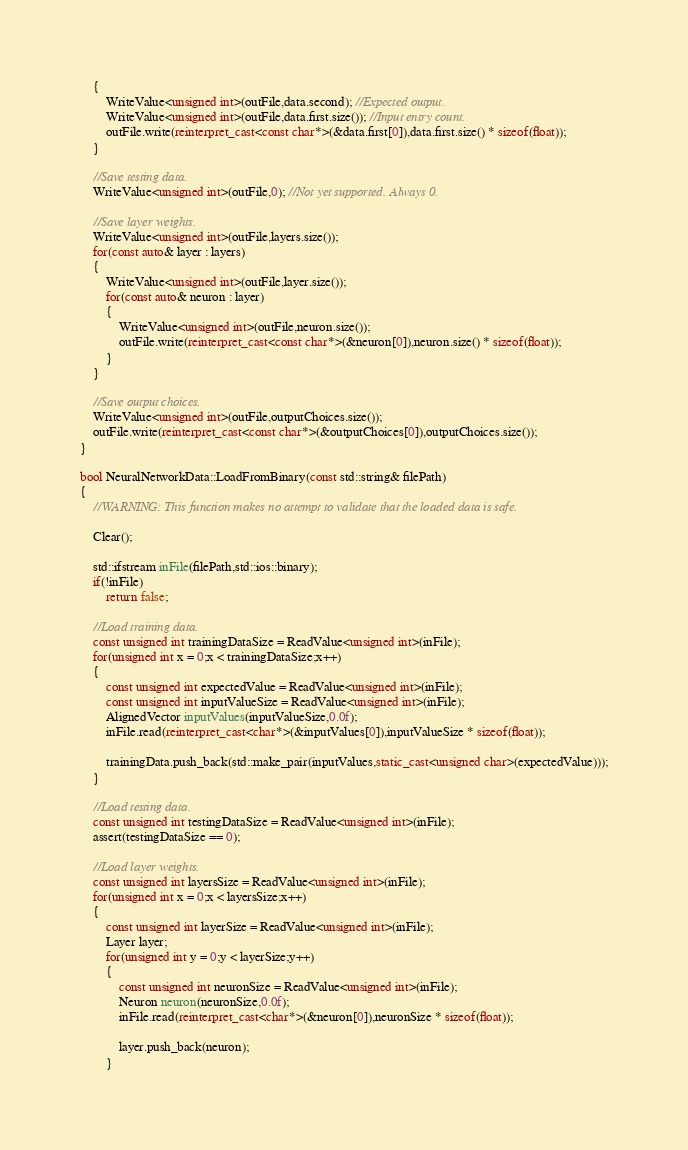Convert code to text. <code><loc_0><loc_0><loc_500><loc_500><_C++_>	{
		WriteValue<unsigned int>(outFile,data.second); //Expected output.
		WriteValue<unsigned int>(outFile,data.first.size()); //Input entry count.
		outFile.write(reinterpret_cast<const char*>(&data.first[0]),data.first.size() * sizeof(float));
	}

	//Save testing data.
	WriteValue<unsigned int>(outFile,0); //Not yet supported. Always 0.

	//Save layer weights.
	WriteValue<unsigned int>(outFile,layers.size());
	for(const auto& layer : layers)
	{
		WriteValue<unsigned int>(outFile,layer.size());
		for(const auto& neuron : layer)
		{
			WriteValue<unsigned int>(outFile,neuron.size());
			outFile.write(reinterpret_cast<const char*>(&neuron[0]),neuron.size() * sizeof(float));
		}
	}

	//Save output choices.
	WriteValue<unsigned int>(outFile,outputChoices.size());
	outFile.write(reinterpret_cast<const char*>(&outputChoices[0]),outputChoices.size());
}

bool NeuralNetworkData::LoadFromBinary(const std::string& filePath)
{
	//WARNING: This function makes no attempt to validate that the loaded data is safe.

	Clear();

	std::ifstream inFile(filePath,std::ios::binary);
	if(!inFile)
		return false;

	//Load training data.
	const unsigned int trainingDataSize = ReadValue<unsigned int>(inFile);
	for(unsigned int x = 0;x < trainingDataSize;x++)
	{
		const unsigned int expectedValue = ReadValue<unsigned int>(inFile);
		const unsigned int inputValueSize = ReadValue<unsigned int>(inFile);
		AlignedVector inputValues(inputValueSize,0.0f);
		inFile.read(reinterpret_cast<char*>(&inputValues[0]),inputValueSize * sizeof(float));

		trainingData.push_back(std::make_pair(inputValues,static_cast<unsigned char>(expectedValue)));
	}

	//Load testing data.
	const unsigned int testingDataSize = ReadValue<unsigned int>(inFile);
	assert(testingDataSize == 0);

	//Load layer weights.
	const unsigned int layersSize = ReadValue<unsigned int>(inFile);
	for(unsigned int x = 0;x < layersSize;x++)
	{
		const unsigned int layerSize = ReadValue<unsigned int>(inFile);
		Layer layer;
		for(unsigned int y = 0;y < layerSize;y++)
		{
			const unsigned int neuronSize = ReadValue<unsigned int>(inFile);
			Neuron neuron(neuronSize,0.0f);
			inFile.read(reinterpret_cast<char*>(&neuron[0]),neuronSize * sizeof(float));

			layer.push_back(neuron);
		}
</code> 